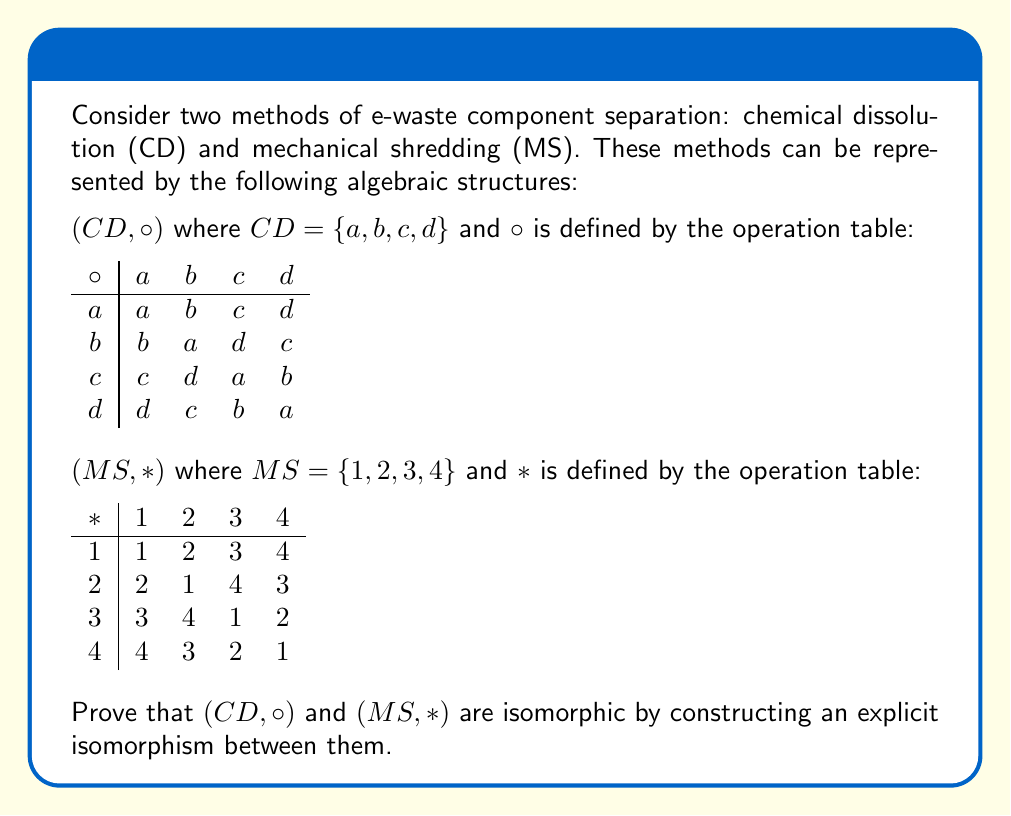Can you solve this math problem? To prove that $(CD, \circ)$ and $(MS, *)$ are isomorphic, we need to find a bijective function $f: CD \to MS$ that preserves the operation structure. Let's approach this step-by-step:

1) First, let's define a mapping $f: CD \to MS$ as follows:
   $f(a) = 1$, $f(b) = 2$, $f(c) = 3$, $f(d) = 4$

2) We need to verify that this mapping is bijective:
   - It's injective (one-to-one) because each element in CD maps to a unique element in MS.
   - It's surjective (onto) because every element in MS is mapped to by an element in CD.
   Therefore, $f$ is bijective.

3) Now, we need to show that $f$ preserves the operation structure. That is, for all $x, y \in CD$:
   $f(x \circ y) = f(x) * f(y)$

4) Let's verify this for all possible combinations:
   
   $f(a \circ a) = f(a) = 1 = 1 * 1 = f(a) * f(a)$
   $f(a \circ b) = f(b) = 2 = 1 * 2 = f(a) * f(b)$
   $f(a \circ c) = f(c) = 3 = 1 * 3 = f(a) * f(c)$
   $f(a \circ d) = f(d) = 4 = 1 * 4 = f(a) * f(d)$

   $f(b \circ a) = f(b) = 2 = 2 * 1 = f(b) * f(a)$
   $f(b \circ b) = f(a) = 1 = 2 * 2 = f(b) * f(b)$
   $f(b \circ c) = f(d) = 4 = 2 * 3 = f(b) * f(c)$
   $f(b \circ d) = f(c) = 3 = 2 * 4 = f(b) * f(d)$

   $f(c \circ a) = f(c) = 3 = 3 * 1 = f(c) * f(a)$
   $f(c \circ b) = f(d) = 4 = 3 * 2 = f(c) * f(b)$
   $f(c \circ c) = f(a) = 1 = 3 * 3 = f(c) * f(c)$
   $f(c \circ d) = f(b) = 2 = 3 * 4 = f(c) * f(d)$

   $f(d \circ a) = f(d) = 4 = 4 * 1 = f(d) * f(a)$
   $f(d \circ b) = f(c) = 3 = 4 * 2 = f(d) * f(b)$
   $f(d \circ c) = f(b) = 2 = 4 * 3 = f(d) * f(c)$
   $f(d \circ d) = f(a) = 1 = 4 * 4 = f(d) * f(d)$

5) We have verified that $f(x \circ y) = f(x) * f(y)$ holds for all $x, y \in CD$.

Therefore, $f$ is an isomorphism between $(CD, \circ)$ and $(MS, *)$, proving that these structures are isomorphic.
Answer: The isomorphism $f: CD \to MS$ is given by $f(a) = 1$, $f(b) = 2$, $f(c) = 3$, $f(d) = 4$. 